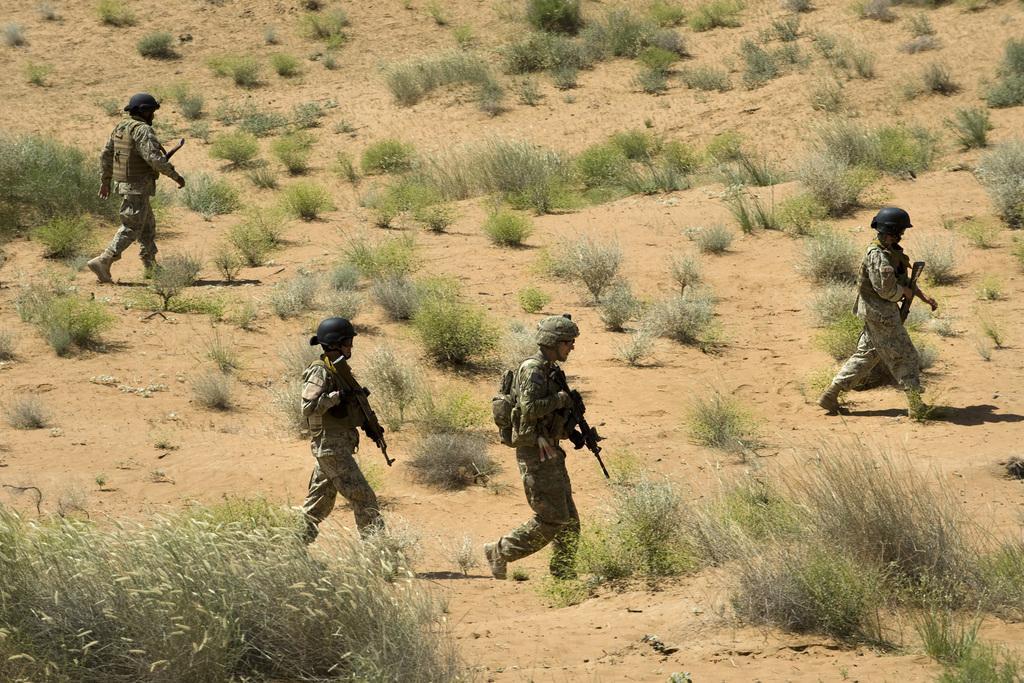How would you summarize this image in a sentence or two? In this picture there are people walking and holding guns and wore helmets. We can see grass and plants. 